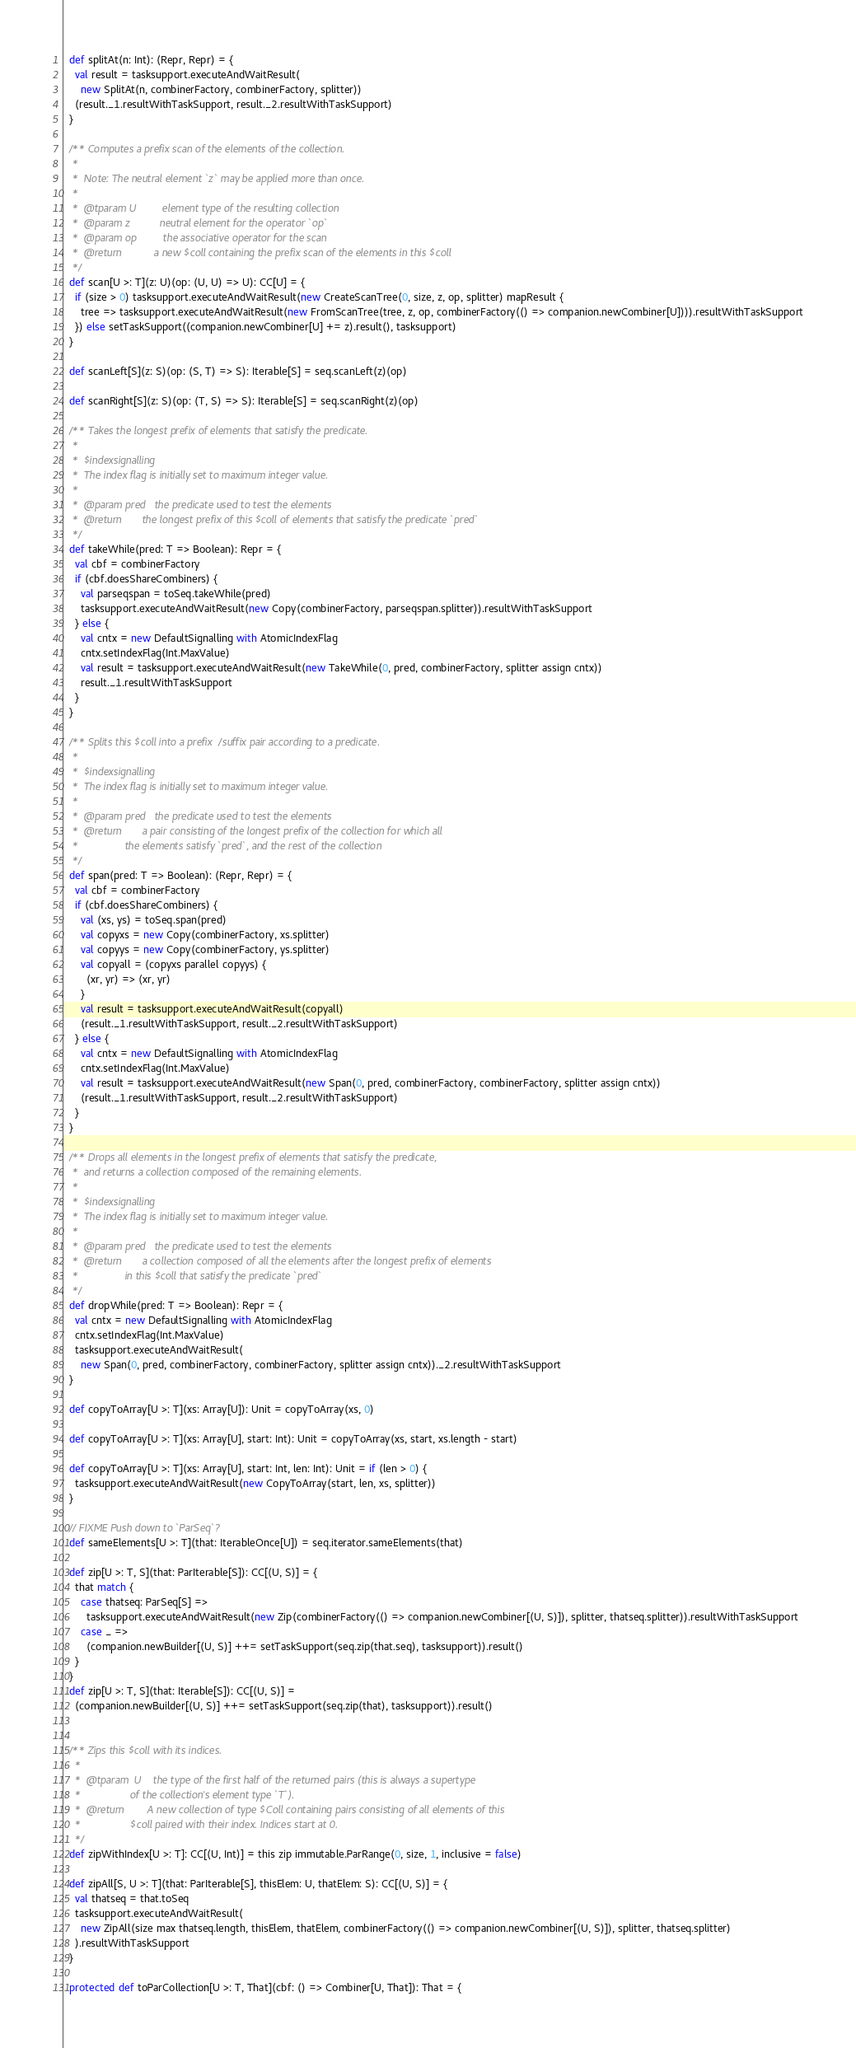<code> <loc_0><loc_0><loc_500><loc_500><_Scala_>
  def splitAt(n: Int): (Repr, Repr) = {
    val result = tasksupport.executeAndWaitResult(
      new SplitAt(n, combinerFactory, combinerFactory, splitter))
    (result._1.resultWithTaskSupport, result._2.resultWithTaskSupport)
  }

  /** Computes a prefix scan of the elements of the collection.
   *
   *  Note: The neutral element `z` may be applied more than once.
   *
   *  @tparam U         element type of the resulting collection
   *  @param z          neutral element for the operator `op`
   *  @param op         the associative operator for the scan
   *  @return           a new $coll containing the prefix scan of the elements in this $coll
   */
  def scan[U >: T](z: U)(op: (U, U) => U): CC[U] = {
    if (size > 0) tasksupport.executeAndWaitResult(new CreateScanTree(0, size, z, op, splitter) mapResult {
      tree => tasksupport.executeAndWaitResult(new FromScanTree(tree, z, op, combinerFactory(() => companion.newCombiner[U]))).resultWithTaskSupport
    }) else setTaskSupport((companion.newCombiner[U] += z).result(), tasksupport)
  }

  def scanLeft[S](z: S)(op: (S, T) => S): Iterable[S] = seq.scanLeft(z)(op)

  def scanRight[S](z: S)(op: (T, S) => S): Iterable[S] = seq.scanRight(z)(op)

  /** Takes the longest prefix of elements that satisfy the predicate.
   *
   *  $indexsignalling
   *  The index flag is initially set to maximum integer value.
   *
   *  @param pred   the predicate used to test the elements
   *  @return       the longest prefix of this $coll of elements that satisfy the predicate `pred`
   */
  def takeWhile(pred: T => Boolean): Repr = {
    val cbf = combinerFactory
    if (cbf.doesShareCombiners) {
      val parseqspan = toSeq.takeWhile(pred)
      tasksupport.executeAndWaitResult(new Copy(combinerFactory, parseqspan.splitter)).resultWithTaskSupport
    } else {
      val cntx = new DefaultSignalling with AtomicIndexFlag
      cntx.setIndexFlag(Int.MaxValue)
      val result = tasksupport.executeAndWaitResult(new TakeWhile(0, pred, combinerFactory, splitter assign cntx))
      result._1.resultWithTaskSupport
    }
  }

  /** Splits this $coll into a prefix/suffix pair according to a predicate.
   *
   *  $indexsignalling
   *  The index flag is initially set to maximum integer value.
   *
   *  @param pred   the predicate used to test the elements
   *  @return       a pair consisting of the longest prefix of the collection for which all
   *                the elements satisfy `pred`, and the rest of the collection
   */
  def span(pred: T => Boolean): (Repr, Repr) = {
    val cbf = combinerFactory
    if (cbf.doesShareCombiners) {
      val (xs, ys) = toSeq.span(pred)
      val copyxs = new Copy(combinerFactory, xs.splitter)
      val copyys = new Copy(combinerFactory, ys.splitter)
      val copyall = (copyxs parallel copyys) {
        (xr, yr) => (xr, yr)
      }
      val result = tasksupport.executeAndWaitResult(copyall)
      (result._1.resultWithTaskSupport, result._2.resultWithTaskSupport)
    } else {
      val cntx = new DefaultSignalling with AtomicIndexFlag
      cntx.setIndexFlag(Int.MaxValue)
      val result = tasksupport.executeAndWaitResult(new Span(0, pred, combinerFactory, combinerFactory, splitter assign cntx))
      (result._1.resultWithTaskSupport, result._2.resultWithTaskSupport)
    }
  }

  /** Drops all elements in the longest prefix of elements that satisfy the predicate,
   *  and returns a collection composed of the remaining elements.
   *
   *  $indexsignalling
   *  The index flag is initially set to maximum integer value.
   *
   *  @param pred   the predicate used to test the elements
   *  @return       a collection composed of all the elements after the longest prefix of elements
   *                in this $coll that satisfy the predicate `pred`
   */
  def dropWhile(pred: T => Boolean): Repr = {
    val cntx = new DefaultSignalling with AtomicIndexFlag
    cntx.setIndexFlag(Int.MaxValue)
    tasksupport.executeAndWaitResult(
      new Span(0, pred, combinerFactory, combinerFactory, splitter assign cntx))._2.resultWithTaskSupport
  }

  def copyToArray[U >: T](xs: Array[U]): Unit = copyToArray(xs, 0)

  def copyToArray[U >: T](xs: Array[U], start: Int): Unit = copyToArray(xs, start, xs.length - start)

  def copyToArray[U >: T](xs: Array[U], start: Int, len: Int): Unit = if (len > 0) {
    tasksupport.executeAndWaitResult(new CopyToArray(start, len, xs, splitter))
  }

  // FIXME Push down to `ParSeq`?
  def sameElements[U >: T](that: IterableOnce[U]) = seq.iterator.sameElements(that)

  def zip[U >: T, S](that: ParIterable[S]): CC[(U, S)] = {
    that match {
      case thatseq: ParSeq[S] =>
        tasksupport.executeAndWaitResult(new Zip(combinerFactory(() => companion.newCombiner[(U, S)]), splitter, thatseq.splitter)).resultWithTaskSupport
      case _ =>
        (companion.newBuilder[(U, S)] ++= setTaskSupport(seq.zip(that.seq), tasksupport)).result()
    }
  }
  def zip[U >: T, S](that: Iterable[S]): CC[(U, S)] =
    (companion.newBuilder[(U, S)] ++= setTaskSupport(seq.zip(that), tasksupport)).result()


  /** Zips this $coll with its indices.
    *
    *  @tparam  U    the type of the first half of the returned pairs (this is always a supertype
    *                 of the collection's element type `T`).
    *  @return        A new collection of type $Coll containing pairs consisting of all elements of this
    *                 $coll paired with their index. Indices start at 0.
    */
  def zipWithIndex[U >: T]: CC[(U, Int)] = this zip immutable.ParRange(0, size, 1, inclusive = false)

  def zipAll[S, U >: T](that: ParIterable[S], thisElem: U, thatElem: S): CC[(U, S)] = {
    val thatseq = that.toSeq
    tasksupport.executeAndWaitResult(
      new ZipAll(size max thatseq.length, thisElem, thatElem, combinerFactory(() => companion.newCombiner[(U, S)]), splitter, thatseq.splitter)
    ).resultWithTaskSupport
  }

  protected def toParCollection[U >: T, That](cbf: () => Combiner[U, That]): That = {</code> 